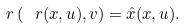Convert formula to latex. <formula><loc_0><loc_0><loc_500><loc_500>\ r \left ( \ r ( x , u ) , v \right ) = \hat { x } ( x , u ) .</formula> 